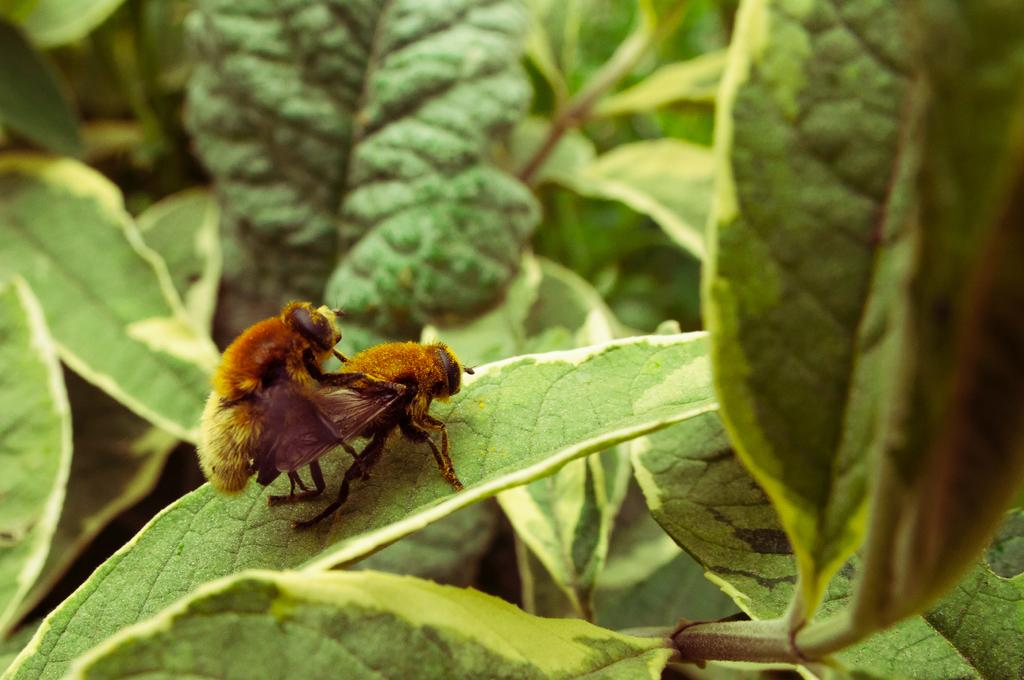What insects can be seen in the image? There are two bees on a leaf in the image. How would you describe the color of the leaf with the bees? The leaf has a light and dark green color combination. Can you describe the overall setting of the image? There are many leaves and plants in the image. What type of basket is hanging from the sign in the image? There is no basket or sign present in the image; it features two bees on a leaf and many plants. 